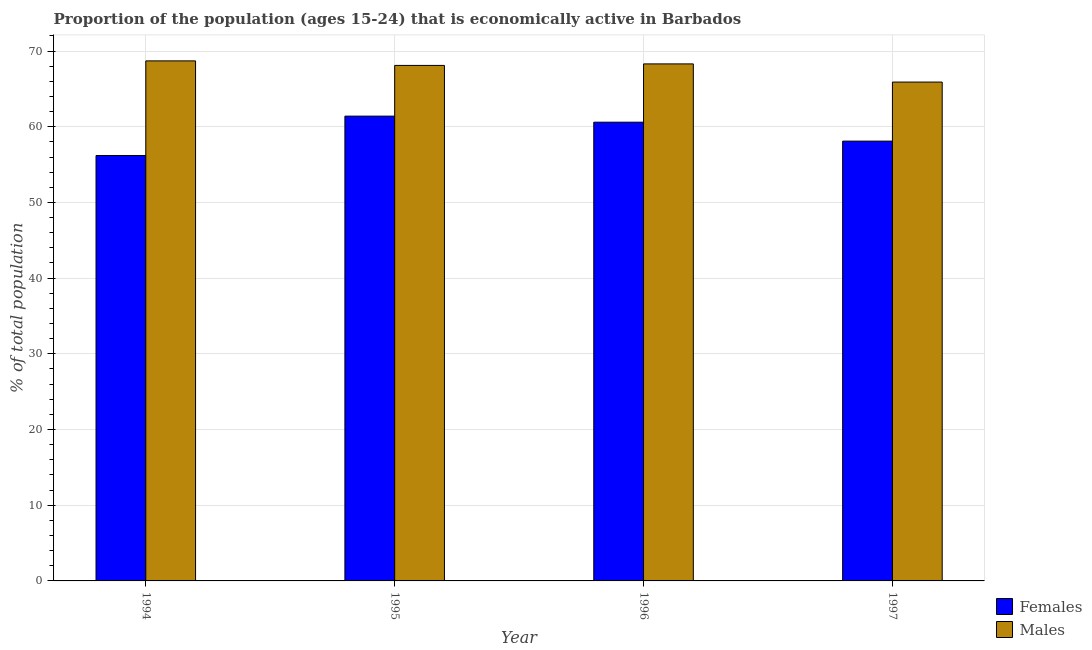How many different coloured bars are there?
Provide a short and direct response. 2. How many bars are there on the 2nd tick from the left?
Your answer should be very brief. 2. What is the label of the 3rd group of bars from the left?
Offer a terse response. 1996. What is the percentage of economically active female population in 1996?
Offer a very short reply. 60.6. Across all years, what is the maximum percentage of economically active female population?
Ensure brevity in your answer.  61.4. Across all years, what is the minimum percentage of economically active female population?
Offer a terse response. 56.2. In which year was the percentage of economically active female population minimum?
Provide a short and direct response. 1994. What is the total percentage of economically active male population in the graph?
Your response must be concise. 271. What is the difference between the percentage of economically active male population in 1996 and that in 1997?
Make the answer very short. 2.4. What is the difference between the percentage of economically active male population in 1994 and the percentage of economically active female population in 1996?
Provide a succinct answer. 0.4. What is the average percentage of economically active male population per year?
Your answer should be very brief. 67.75. In the year 1996, what is the difference between the percentage of economically active male population and percentage of economically active female population?
Ensure brevity in your answer.  0. What is the ratio of the percentage of economically active female population in 1994 to that in 1997?
Your response must be concise. 0.97. Is the percentage of economically active male population in 1994 less than that in 1997?
Offer a terse response. No. What is the difference between the highest and the second highest percentage of economically active female population?
Make the answer very short. 0.8. What is the difference between the highest and the lowest percentage of economically active female population?
Make the answer very short. 5.2. In how many years, is the percentage of economically active female population greater than the average percentage of economically active female population taken over all years?
Provide a short and direct response. 2. Is the sum of the percentage of economically active male population in 1994 and 1995 greater than the maximum percentage of economically active female population across all years?
Offer a terse response. Yes. What does the 2nd bar from the left in 1997 represents?
Make the answer very short. Males. What does the 1st bar from the right in 1996 represents?
Provide a succinct answer. Males. How many bars are there?
Ensure brevity in your answer.  8. Are all the bars in the graph horizontal?
Keep it short and to the point. No. Does the graph contain any zero values?
Ensure brevity in your answer.  No. How are the legend labels stacked?
Your answer should be very brief. Vertical. What is the title of the graph?
Keep it short and to the point. Proportion of the population (ages 15-24) that is economically active in Barbados. Does "Grants" appear as one of the legend labels in the graph?
Provide a short and direct response. No. What is the label or title of the X-axis?
Offer a terse response. Year. What is the label or title of the Y-axis?
Offer a terse response. % of total population. What is the % of total population in Females in 1994?
Your answer should be very brief. 56.2. What is the % of total population of Males in 1994?
Ensure brevity in your answer.  68.7. What is the % of total population in Females in 1995?
Give a very brief answer. 61.4. What is the % of total population of Males in 1995?
Your response must be concise. 68.1. What is the % of total population of Females in 1996?
Make the answer very short. 60.6. What is the % of total population in Males in 1996?
Provide a short and direct response. 68.3. What is the % of total population of Females in 1997?
Your response must be concise. 58.1. What is the % of total population of Males in 1997?
Make the answer very short. 65.9. Across all years, what is the maximum % of total population of Females?
Your answer should be very brief. 61.4. Across all years, what is the maximum % of total population in Males?
Your response must be concise. 68.7. Across all years, what is the minimum % of total population in Females?
Make the answer very short. 56.2. Across all years, what is the minimum % of total population of Males?
Give a very brief answer. 65.9. What is the total % of total population in Females in the graph?
Your answer should be compact. 236.3. What is the total % of total population in Males in the graph?
Your answer should be compact. 271. What is the difference between the % of total population in Males in 1994 and that in 1995?
Your response must be concise. 0.6. What is the difference between the % of total population of Males in 1995 and that in 1996?
Offer a very short reply. -0.2. What is the difference between the % of total population of Females in 1995 and that in 1997?
Give a very brief answer. 3.3. What is the difference between the % of total population in Males in 1995 and that in 1997?
Provide a short and direct response. 2.2. What is the difference between the % of total population of Females in 1994 and the % of total population of Males in 1996?
Provide a succinct answer. -12.1. What is the difference between the % of total population of Females in 1995 and the % of total population of Males in 1996?
Your answer should be very brief. -6.9. What is the average % of total population in Females per year?
Your answer should be very brief. 59.08. What is the average % of total population of Males per year?
Offer a terse response. 67.75. In the year 1996, what is the difference between the % of total population in Females and % of total population in Males?
Give a very brief answer. -7.7. What is the ratio of the % of total population of Females in 1994 to that in 1995?
Provide a succinct answer. 0.92. What is the ratio of the % of total population in Males in 1994 to that in 1995?
Offer a very short reply. 1.01. What is the ratio of the % of total population of Females in 1994 to that in 1996?
Ensure brevity in your answer.  0.93. What is the ratio of the % of total population in Males in 1994 to that in 1996?
Offer a very short reply. 1.01. What is the ratio of the % of total population of Females in 1994 to that in 1997?
Your response must be concise. 0.97. What is the ratio of the % of total population in Males in 1994 to that in 1997?
Keep it short and to the point. 1.04. What is the ratio of the % of total population of Females in 1995 to that in 1996?
Your answer should be very brief. 1.01. What is the ratio of the % of total population in Males in 1995 to that in 1996?
Offer a very short reply. 1. What is the ratio of the % of total population in Females in 1995 to that in 1997?
Your response must be concise. 1.06. What is the ratio of the % of total population of Males in 1995 to that in 1997?
Keep it short and to the point. 1.03. What is the ratio of the % of total population of Females in 1996 to that in 1997?
Ensure brevity in your answer.  1.04. What is the ratio of the % of total population of Males in 1996 to that in 1997?
Offer a terse response. 1.04. What is the difference between the highest and the lowest % of total population of Females?
Your answer should be compact. 5.2. What is the difference between the highest and the lowest % of total population in Males?
Offer a very short reply. 2.8. 